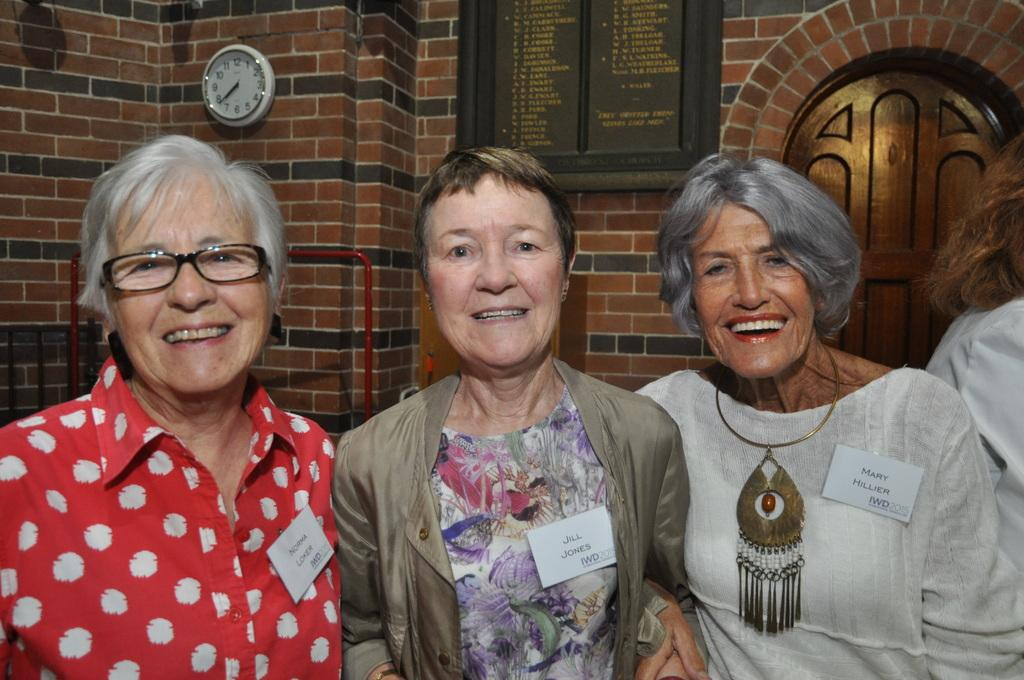How many people are in the image? There are four people in the image. What is the facial expression of most of the people in the image? Three of the people are smiling. What can be seen on the people in the image? There are name cards on the people. What is visible in the background of the image? There is a wall, a name board, a clock, and a door in the background of the image. What type of song is being sung by the squirrel in the image? There is no squirrel present in the image, and therefore no such activity can be observed. 